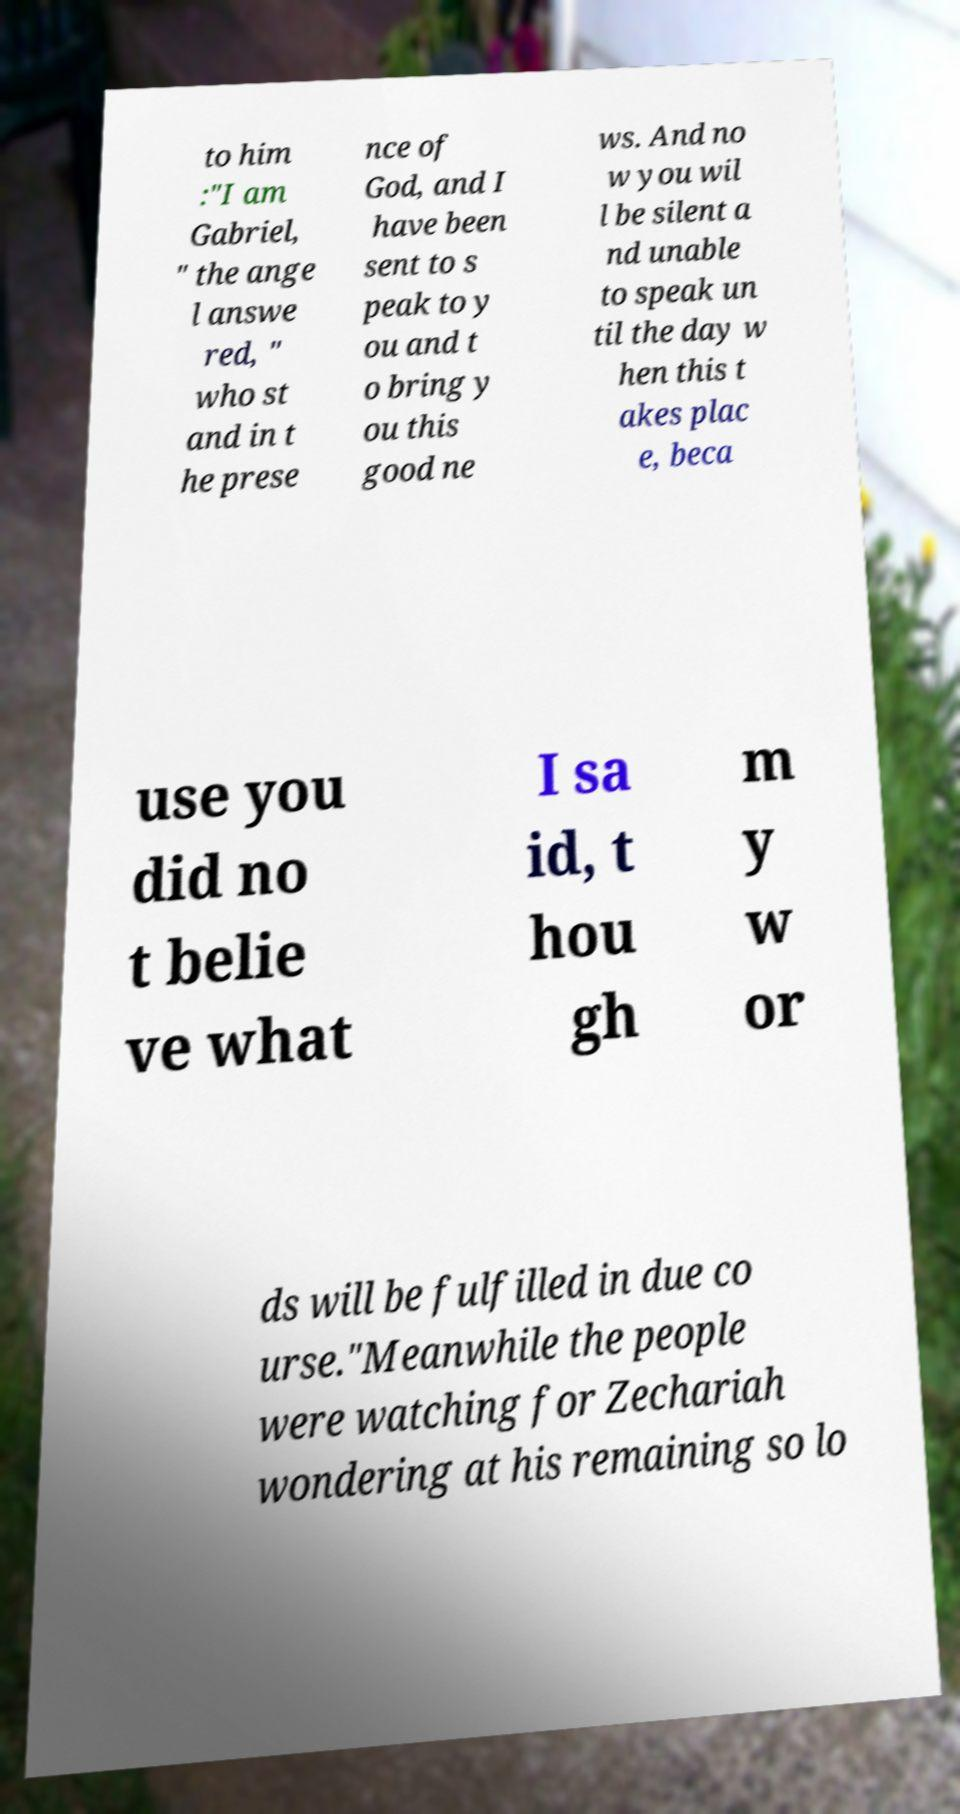Can you read and provide the text displayed in the image?This photo seems to have some interesting text. Can you extract and type it out for me? to him :"I am Gabriel, " the ange l answe red, " who st and in t he prese nce of God, and I have been sent to s peak to y ou and t o bring y ou this good ne ws. And no w you wil l be silent a nd unable to speak un til the day w hen this t akes plac e, beca use you did no t belie ve what I sa id, t hou gh m y w or ds will be fulfilled in due co urse."Meanwhile the people were watching for Zechariah wondering at his remaining so lo 